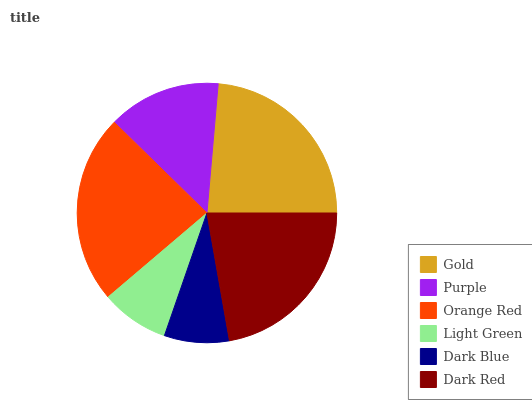Is Dark Blue the minimum?
Answer yes or no. Yes. Is Gold the maximum?
Answer yes or no. Yes. Is Purple the minimum?
Answer yes or no. No. Is Purple the maximum?
Answer yes or no. No. Is Gold greater than Purple?
Answer yes or no. Yes. Is Purple less than Gold?
Answer yes or no. Yes. Is Purple greater than Gold?
Answer yes or no. No. Is Gold less than Purple?
Answer yes or no. No. Is Dark Red the high median?
Answer yes or no. Yes. Is Purple the low median?
Answer yes or no. Yes. Is Purple the high median?
Answer yes or no. No. Is Orange Red the low median?
Answer yes or no. No. 